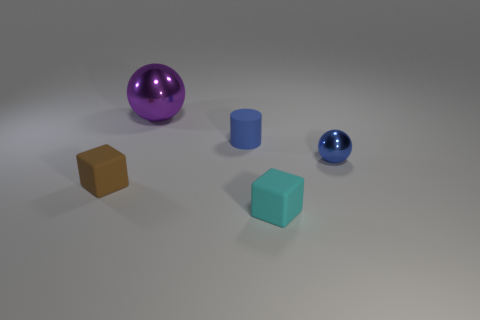Add 4 tiny blue shiny objects. How many objects exist? 9 Subtract all cubes. How many objects are left? 3 Add 1 blue spheres. How many blue spheres are left? 2 Add 5 small blue balls. How many small blue balls exist? 6 Subtract 0 red balls. How many objects are left? 5 Subtract all small spheres. Subtract all brown objects. How many objects are left? 3 